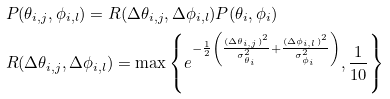<formula> <loc_0><loc_0><loc_500><loc_500>& P ( \theta _ { i , j } , \phi _ { i , l } ) = R ( \Delta \theta _ { i , j } , \Delta \phi _ { i , l } ) P ( \theta _ { i } , \phi _ { i } ) \\ & R ( \Delta \theta _ { i , j } , \Delta \phi _ { i , l } ) = \max \left \{ e ^ { - \frac { 1 } { 2 } \left ( \frac { ( \Delta \theta _ { i , j } ) ^ { 2 } } { \sigma _ { \theta _ { i } } ^ { 2 } } + \frac { ( \Delta \phi _ { i , l } ) ^ { 2 } } { \sigma _ { \phi _ { i } } ^ { 2 } } \right ) } , \frac { 1 } { 1 0 } \right \}</formula> 